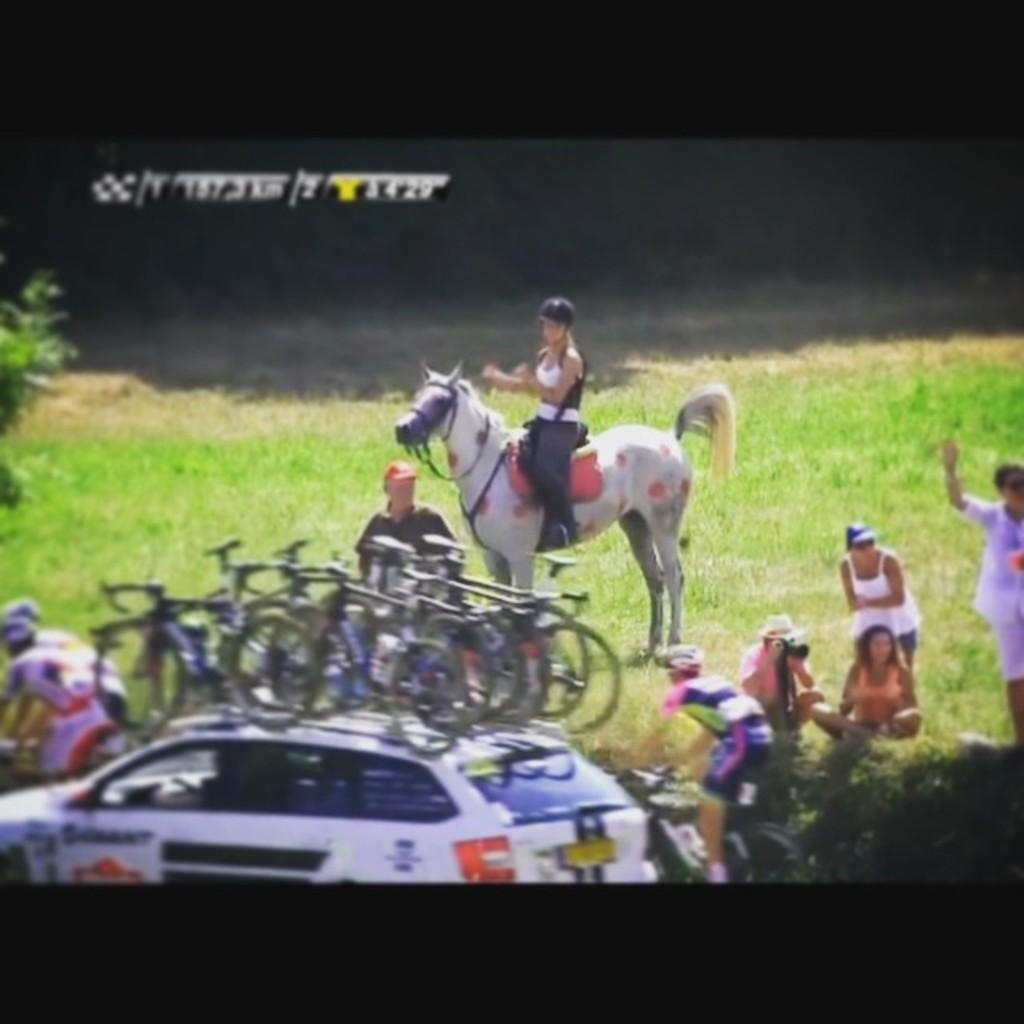What is the girl doing in the image? The girl is sitting on a horse. Are there any other people in the image? Yes, there are people beside the girl. What are the people beside the girl doing? The people are waving to cyclists. What type of event is taking place in the image? There is an event taking place, but the specific event is not mentioned in the facts. What is the car following in the image? The car is following the cyclists. What is on the car? The car has bicycles on it. How many houses are visible in the image? There is no mention of houses in the provided facts, so we cannot determine the number of houses in the image. What type of chair is the secretary sitting on? There is no secretary or chair present in the image. 